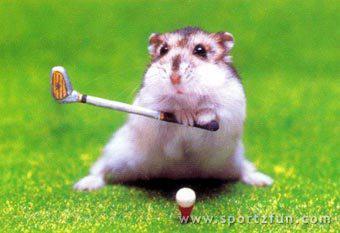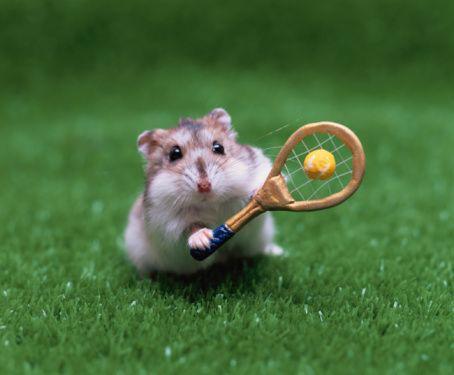The first image is the image on the left, the second image is the image on the right. Analyze the images presented: Is the assertion "A small rodent is holding a tennis racket." valid? Answer yes or no. Yes. The first image is the image on the left, the second image is the image on the right. Evaluate the accuracy of this statement regarding the images: "There is a hamster holding a tennis racket.". Is it true? Answer yes or no. Yes. 